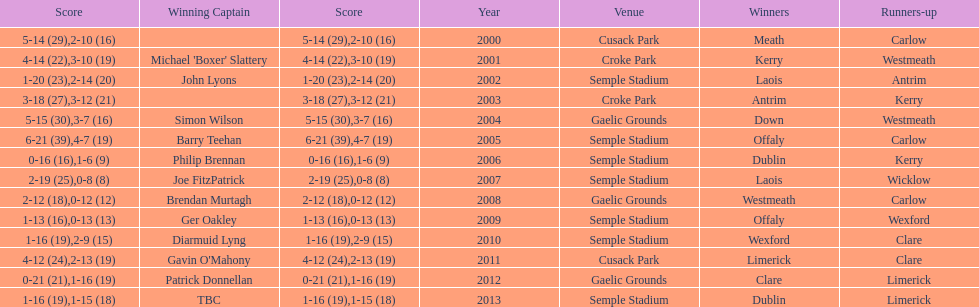Who scored the least? Wicklow. 